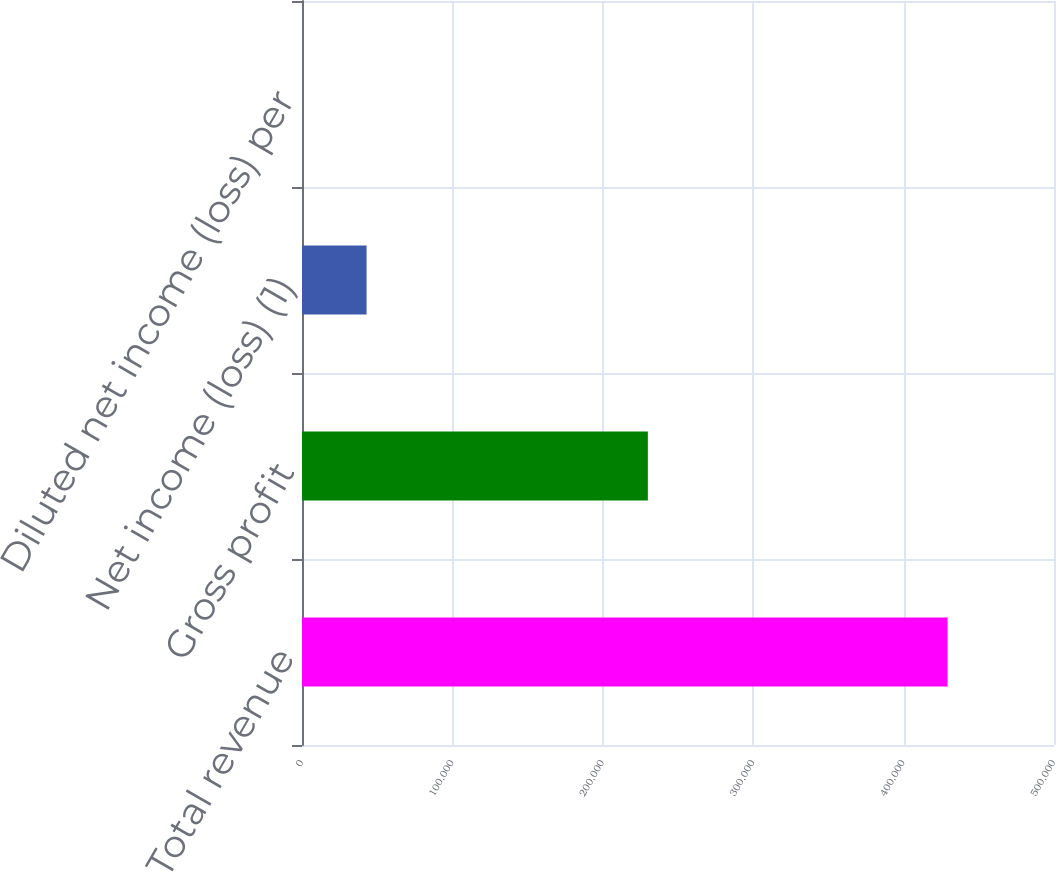<chart> <loc_0><loc_0><loc_500><loc_500><bar_chart><fcel>Total revenue<fcel>Gross profit<fcel>Net income (loss) (1)<fcel>Diluted net income (loss) per<nl><fcel>429233<fcel>229959<fcel>42923.4<fcel>0.15<nl></chart> 